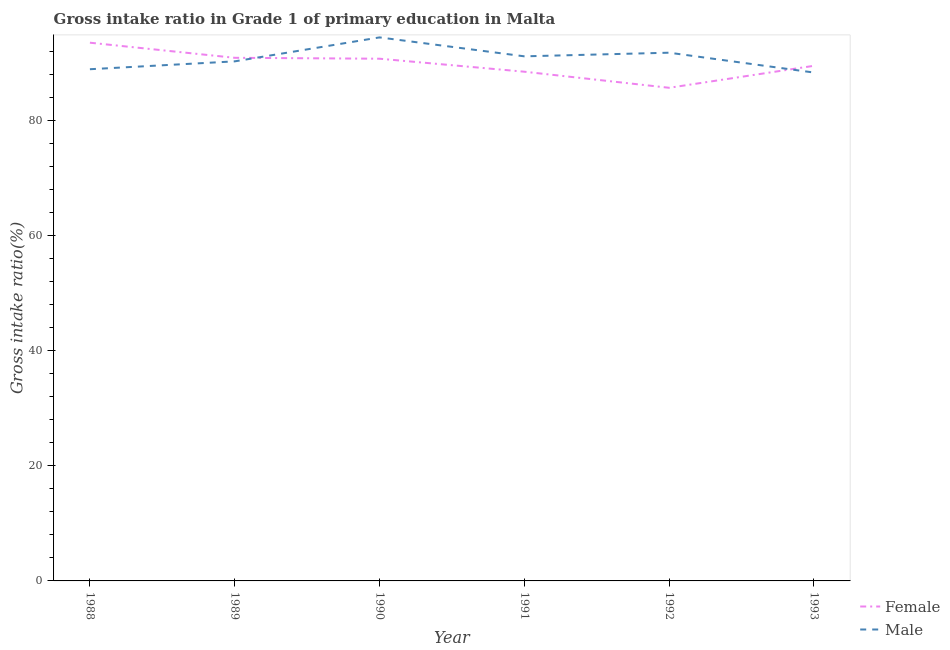What is the gross intake ratio(male) in 1993?
Your response must be concise. 88.36. Across all years, what is the maximum gross intake ratio(male)?
Make the answer very short. 94.47. Across all years, what is the minimum gross intake ratio(male)?
Give a very brief answer. 88.36. In which year was the gross intake ratio(female) maximum?
Your answer should be very brief. 1988. What is the total gross intake ratio(male) in the graph?
Provide a succinct answer. 545.05. What is the difference between the gross intake ratio(male) in 1988 and that in 1993?
Your answer should be compact. 0.58. What is the difference between the gross intake ratio(male) in 1993 and the gross intake ratio(female) in 1992?
Provide a short and direct response. 2.65. What is the average gross intake ratio(female) per year?
Offer a terse response. 89.83. In the year 1988, what is the difference between the gross intake ratio(male) and gross intake ratio(female)?
Ensure brevity in your answer.  -4.61. What is the ratio of the gross intake ratio(female) in 1990 to that in 1993?
Your answer should be very brief. 1.01. Is the gross intake ratio(female) in 1989 less than that in 1991?
Ensure brevity in your answer.  No. What is the difference between the highest and the second highest gross intake ratio(female)?
Provide a succinct answer. 2.63. What is the difference between the highest and the lowest gross intake ratio(female)?
Make the answer very short. 7.84. Does the gross intake ratio(male) monotonically increase over the years?
Your response must be concise. No. Is the gross intake ratio(male) strictly greater than the gross intake ratio(female) over the years?
Your answer should be compact. No. How many lines are there?
Your response must be concise. 2. How many years are there in the graph?
Make the answer very short. 6. Are the values on the major ticks of Y-axis written in scientific E-notation?
Keep it short and to the point. No. Does the graph contain any zero values?
Ensure brevity in your answer.  No. Does the graph contain grids?
Keep it short and to the point. No. How many legend labels are there?
Make the answer very short. 2. How are the legend labels stacked?
Make the answer very short. Vertical. What is the title of the graph?
Your response must be concise. Gross intake ratio in Grade 1 of primary education in Malta. Does "Number of departures" appear as one of the legend labels in the graph?
Keep it short and to the point. No. What is the label or title of the Y-axis?
Offer a very short reply. Gross intake ratio(%). What is the Gross intake ratio(%) in Female in 1988?
Your response must be concise. 93.55. What is the Gross intake ratio(%) in Male in 1988?
Your response must be concise. 88.94. What is the Gross intake ratio(%) in Female in 1989?
Your answer should be compact. 90.92. What is the Gross intake ratio(%) of Male in 1989?
Provide a short and direct response. 90.3. What is the Gross intake ratio(%) of Female in 1990?
Offer a terse response. 90.76. What is the Gross intake ratio(%) in Male in 1990?
Give a very brief answer. 94.47. What is the Gross intake ratio(%) of Female in 1991?
Your answer should be very brief. 88.5. What is the Gross intake ratio(%) of Male in 1991?
Ensure brevity in your answer.  91.18. What is the Gross intake ratio(%) of Female in 1992?
Make the answer very short. 85.71. What is the Gross intake ratio(%) in Male in 1992?
Your answer should be very brief. 91.81. What is the Gross intake ratio(%) of Female in 1993?
Offer a terse response. 89.53. What is the Gross intake ratio(%) in Male in 1993?
Your answer should be compact. 88.36. Across all years, what is the maximum Gross intake ratio(%) in Female?
Keep it short and to the point. 93.55. Across all years, what is the maximum Gross intake ratio(%) in Male?
Ensure brevity in your answer.  94.47. Across all years, what is the minimum Gross intake ratio(%) of Female?
Offer a terse response. 85.71. Across all years, what is the minimum Gross intake ratio(%) in Male?
Provide a succinct answer. 88.36. What is the total Gross intake ratio(%) in Female in the graph?
Keep it short and to the point. 538.98. What is the total Gross intake ratio(%) in Male in the graph?
Keep it short and to the point. 545.05. What is the difference between the Gross intake ratio(%) of Female in 1988 and that in 1989?
Provide a short and direct response. 2.63. What is the difference between the Gross intake ratio(%) in Male in 1988 and that in 1989?
Offer a terse response. -1.37. What is the difference between the Gross intake ratio(%) of Female in 1988 and that in 1990?
Keep it short and to the point. 2.78. What is the difference between the Gross intake ratio(%) in Male in 1988 and that in 1990?
Ensure brevity in your answer.  -5.53. What is the difference between the Gross intake ratio(%) of Female in 1988 and that in 1991?
Provide a succinct answer. 5.04. What is the difference between the Gross intake ratio(%) of Male in 1988 and that in 1991?
Your answer should be very brief. -2.24. What is the difference between the Gross intake ratio(%) in Female in 1988 and that in 1992?
Provide a succinct answer. 7.84. What is the difference between the Gross intake ratio(%) in Male in 1988 and that in 1992?
Give a very brief answer. -2.87. What is the difference between the Gross intake ratio(%) of Female in 1988 and that in 1993?
Your response must be concise. 4.01. What is the difference between the Gross intake ratio(%) in Male in 1988 and that in 1993?
Your response must be concise. 0.58. What is the difference between the Gross intake ratio(%) in Female in 1989 and that in 1990?
Your answer should be compact. 0.16. What is the difference between the Gross intake ratio(%) in Male in 1989 and that in 1990?
Make the answer very short. -4.16. What is the difference between the Gross intake ratio(%) in Female in 1989 and that in 1991?
Your answer should be very brief. 2.42. What is the difference between the Gross intake ratio(%) of Male in 1989 and that in 1991?
Provide a succinct answer. -0.87. What is the difference between the Gross intake ratio(%) of Female in 1989 and that in 1992?
Provide a short and direct response. 5.21. What is the difference between the Gross intake ratio(%) in Male in 1989 and that in 1992?
Your response must be concise. -1.5. What is the difference between the Gross intake ratio(%) of Female in 1989 and that in 1993?
Offer a very short reply. 1.39. What is the difference between the Gross intake ratio(%) of Male in 1989 and that in 1993?
Offer a terse response. 1.95. What is the difference between the Gross intake ratio(%) of Female in 1990 and that in 1991?
Provide a short and direct response. 2.26. What is the difference between the Gross intake ratio(%) of Male in 1990 and that in 1991?
Give a very brief answer. 3.29. What is the difference between the Gross intake ratio(%) in Female in 1990 and that in 1992?
Ensure brevity in your answer.  5.05. What is the difference between the Gross intake ratio(%) of Male in 1990 and that in 1992?
Provide a succinct answer. 2.66. What is the difference between the Gross intake ratio(%) of Female in 1990 and that in 1993?
Provide a succinct answer. 1.23. What is the difference between the Gross intake ratio(%) in Male in 1990 and that in 1993?
Offer a very short reply. 6.11. What is the difference between the Gross intake ratio(%) of Female in 1991 and that in 1992?
Your answer should be very brief. 2.79. What is the difference between the Gross intake ratio(%) in Male in 1991 and that in 1992?
Your response must be concise. -0.63. What is the difference between the Gross intake ratio(%) of Female in 1991 and that in 1993?
Your answer should be compact. -1.03. What is the difference between the Gross intake ratio(%) of Male in 1991 and that in 1993?
Offer a terse response. 2.82. What is the difference between the Gross intake ratio(%) of Female in 1992 and that in 1993?
Your answer should be compact. -3.82. What is the difference between the Gross intake ratio(%) of Male in 1992 and that in 1993?
Offer a very short reply. 3.45. What is the difference between the Gross intake ratio(%) of Female in 1988 and the Gross intake ratio(%) of Male in 1989?
Provide a short and direct response. 3.24. What is the difference between the Gross intake ratio(%) of Female in 1988 and the Gross intake ratio(%) of Male in 1990?
Ensure brevity in your answer.  -0.92. What is the difference between the Gross intake ratio(%) in Female in 1988 and the Gross intake ratio(%) in Male in 1991?
Offer a terse response. 2.37. What is the difference between the Gross intake ratio(%) in Female in 1988 and the Gross intake ratio(%) in Male in 1992?
Your response must be concise. 1.74. What is the difference between the Gross intake ratio(%) of Female in 1988 and the Gross intake ratio(%) of Male in 1993?
Offer a very short reply. 5.19. What is the difference between the Gross intake ratio(%) in Female in 1989 and the Gross intake ratio(%) in Male in 1990?
Ensure brevity in your answer.  -3.55. What is the difference between the Gross intake ratio(%) of Female in 1989 and the Gross intake ratio(%) of Male in 1991?
Your answer should be compact. -0.26. What is the difference between the Gross intake ratio(%) in Female in 1989 and the Gross intake ratio(%) in Male in 1992?
Provide a succinct answer. -0.89. What is the difference between the Gross intake ratio(%) of Female in 1989 and the Gross intake ratio(%) of Male in 1993?
Keep it short and to the point. 2.56. What is the difference between the Gross intake ratio(%) in Female in 1990 and the Gross intake ratio(%) in Male in 1991?
Provide a succinct answer. -0.41. What is the difference between the Gross intake ratio(%) in Female in 1990 and the Gross intake ratio(%) in Male in 1992?
Give a very brief answer. -1.04. What is the difference between the Gross intake ratio(%) in Female in 1990 and the Gross intake ratio(%) in Male in 1993?
Offer a terse response. 2.41. What is the difference between the Gross intake ratio(%) of Female in 1991 and the Gross intake ratio(%) of Male in 1992?
Your answer should be compact. -3.3. What is the difference between the Gross intake ratio(%) of Female in 1991 and the Gross intake ratio(%) of Male in 1993?
Give a very brief answer. 0.15. What is the difference between the Gross intake ratio(%) in Female in 1992 and the Gross intake ratio(%) in Male in 1993?
Give a very brief answer. -2.65. What is the average Gross intake ratio(%) of Female per year?
Keep it short and to the point. 89.83. What is the average Gross intake ratio(%) in Male per year?
Make the answer very short. 90.84. In the year 1988, what is the difference between the Gross intake ratio(%) of Female and Gross intake ratio(%) of Male?
Give a very brief answer. 4.61. In the year 1989, what is the difference between the Gross intake ratio(%) of Female and Gross intake ratio(%) of Male?
Provide a short and direct response. 0.62. In the year 1990, what is the difference between the Gross intake ratio(%) of Female and Gross intake ratio(%) of Male?
Your answer should be compact. -3.7. In the year 1991, what is the difference between the Gross intake ratio(%) of Female and Gross intake ratio(%) of Male?
Offer a very short reply. -2.67. In the year 1992, what is the difference between the Gross intake ratio(%) of Female and Gross intake ratio(%) of Male?
Your answer should be compact. -6.1. In the year 1993, what is the difference between the Gross intake ratio(%) of Female and Gross intake ratio(%) of Male?
Keep it short and to the point. 1.18. What is the ratio of the Gross intake ratio(%) of Female in 1988 to that in 1989?
Give a very brief answer. 1.03. What is the ratio of the Gross intake ratio(%) of Female in 1988 to that in 1990?
Provide a short and direct response. 1.03. What is the ratio of the Gross intake ratio(%) in Male in 1988 to that in 1990?
Make the answer very short. 0.94. What is the ratio of the Gross intake ratio(%) in Female in 1988 to that in 1991?
Your response must be concise. 1.06. What is the ratio of the Gross intake ratio(%) of Male in 1988 to that in 1991?
Make the answer very short. 0.98. What is the ratio of the Gross intake ratio(%) of Female in 1988 to that in 1992?
Provide a short and direct response. 1.09. What is the ratio of the Gross intake ratio(%) in Male in 1988 to that in 1992?
Offer a terse response. 0.97. What is the ratio of the Gross intake ratio(%) of Female in 1988 to that in 1993?
Provide a succinct answer. 1.04. What is the ratio of the Gross intake ratio(%) in Male in 1988 to that in 1993?
Offer a very short reply. 1.01. What is the ratio of the Gross intake ratio(%) of Female in 1989 to that in 1990?
Ensure brevity in your answer.  1. What is the ratio of the Gross intake ratio(%) of Male in 1989 to that in 1990?
Ensure brevity in your answer.  0.96. What is the ratio of the Gross intake ratio(%) in Female in 1989 to that in 1991?
Your response must be concise. 1.03. What is the ratio of the Gross intake ratio(%) of Female in 1989 to that in 1992?
Your answer should be very brief. 1.06. What is the ratio of the Gross intake ratio(%) of Male in 1989 to that in 1992?
Make the answer very short. 0.98. What is the ratio of the Gross intake ratio(%) in Female in 1989 to that in 1993?
Keep it short and to the point. 1.02. What is the ratio of the Gross intake ratio(%) of Male in 1989 to that in 1993?
Offer a very short reply. 1.02. What is the ratio of the Gross intake ratio(%) in Female in 1990 to that in 1991?
Make the answer very short. 1.03. What is the ratio of the Gross intake ratio(%) of Male in 1990 to that in 1991?
Make the answer very short. 1.04. What is the ratio of the Gross intake ratio(%) of Female in 1990 to that in 1992?
Ensure brevity in your answer.  1.06. What is the ratio of the Gross intake ratio(%) in Male in 1990 to that in 1992?
Make the answer very short. 1.03. What is the ratio of the Gross intake ratio(%) of Female in 1990 to that in 1993?
Give a very brief answer. 1.01. What is the ratio of the Gross intake ratio(%) in Male in 1990 to that in 1993?
Make the answer very short. 1.07. What is the ratio of the Gross intake ratio(%) of Female in 1991 to that in 1992?
Give a very brief answer. 1.03. What is the ratio of the Gross intake ratio(%) of Female in 1991 to that in 1993?
Provide a succinct answer. 0.99. What is the ratio of the Gross intake ratio(%) of Male in 1991 to that in 1993?
Provide a succinct answer. 1.03. What is the ratio of the Gross intake ratio(%) in Female in 1992 to that in 1993?
Your answer should be compact. 0.96. What is the ratio of the Gross intake ratio(%) of Male in 1992 to that in 1993?
Your answer should be compact. 1.04. What is the difference between the highest and the second highest Gross intake ratio(%) in Female?
Provide a succinct answer. 2.63. What is the difference between the highest and the second highest Gross intake ratio(%) in Male?
Give a very brief answer. 2.66. What is the difference between the highest and the lowest Gross intake ratio(%) in Female?
Make the answer very short. 7.84. What is the difference between the highest and the lowest Gross intake ratio(%) in Male?
Your response must be concise. 6.11. 